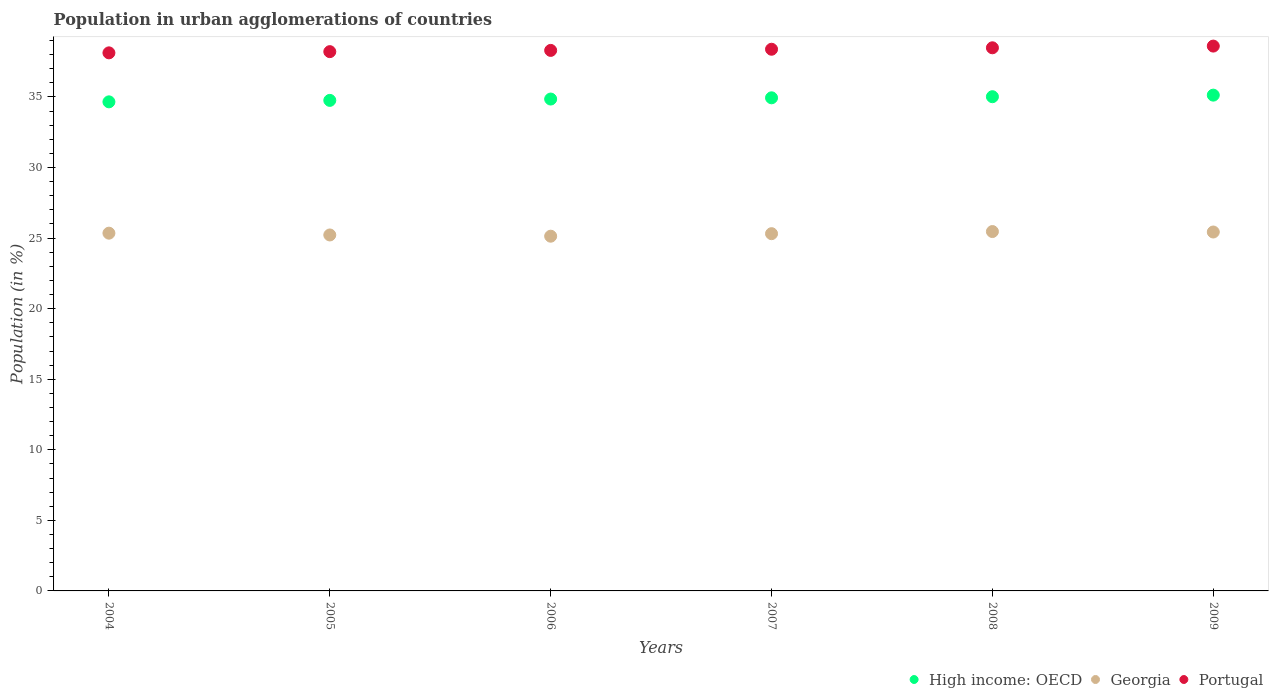What is the percentage of population in urban agglomerations in Portugal in 2005?
Offer a very short reply. 38.21. Across all years, what is the maximum percentage of population in urban agglomerations in Georgia?
Provide a succinct answer. 25.46. Across all years, what is the minimum percentage of population in urban agglomerations in Portugal?
Make the answer very short. 38.13. What is the total percentage of population in urban agglomerations in Georgia in the graph?
Your answer should be very brief. 151.92. What is the difference between the percentage of population in urban agglomerations in Georgia in 2004 and that in 2008?
Provide a succinct answer. -0.11. What is the difference between the percentage of population in urban agglomerations in High income: OECD in 2006 and the percentage of population in urban agglomerations in Portugal in 2008?
Provide a succinct answer. -3.63. What is the average percentage of population in urban agglomerations in Georgia per year?
Offer a very short reply. 25.32. In the year 2008, what is the difference between the percentage of population in urban agglomerations in Portugal and percentage of population in urban agglomerations in High income: OECD?
Provide a succinct answer. 3.47. What is the ratio of the percentage of population in urban agglomerations in Portugal in 2004 to that in 2008?
Provide a short and direct response. 0.99. Is the percentage of population in urban agglomerations in Georgia in 2005 less than that in 2008?
Provide a succinct answer. Yes. Is the difference between the percentage of population in urban agglomerations in Portugal in 2004 and 2006 greater than the difference between the percentage of population in urban agglomerations in High income: OECD in 2004 and 2006?
Provide a short and direct response. Yes. What is the difference between the highest and the second highest percentage of population in urban agglomerations in High income: OECD?
Keep it short and to the point. 0.11. What is the difference between the highest and the lowest percentage of population in urban agglomerations in High income: OECD?
Offer a terse response. 0.48. Is the percentage of population in urban agglomerations in High income: OECD strictly greater than the percentage of population in urban agglomerations in Portugal over the years?
Your response must be concise. No. Is the percentage of population in urban agglomerations in High income: OECD strictly less than the percentage of population in urban agglomerations in Portugal over the years?
Offer a very short reply. Yes. How many years are there in the graph?
Make the answer very short. 6. What is the difference between two consecutive major ticks on the Y-axis?
Ensure brevity in your answer.  5. Are the values on the major ticks of Y-axis written in scientific E-notation?
Make the answer very short. No. Does the graph contain any zero values?
Provide a succinct answer. No. Where does the legend appear in the graph?
Keep it short and to the point. Bottom right. How are the legend labels stacked?
Your answer should be compact. Horizontal. What is the title of the graph?
Your response must be concise. Population in urban agglomerations of countries. Does "Myanmar" appear as one of the legend labels in the graph?
Ensure brevity in your answer.  No. What is the label or title of the Y-axis?
Provide a succinct answer. Population (in %). What is the Population (in %) of High income: OECD in 2004?
Your answer should be very brief. 34.66. What is the Population (in %) in Georgia in 2004?
Offer a very short reply. 25.35. What is the Population (in %) of Portugal in 2004?
Ensure brevity in your answer.  38.13. What is the Population (in %) of High income: OECD in 2005?
Provide a short and direct response. 34.76. What is the Population (in %) in Georgia in 2005?
Give a very brief answer. 25.22. What is the Population (in %) of Portugal in 2005?
Make the answer very short. 38.21. What is the Population (in %) of High income: OECD in 2006?
Offer a very short reply. 34.85. What is the Population (in %) of Georgia in 2006?
Your answer should be very brief. 25.14. What is the Population (in %) in Portugal in 2006?
Offer a very short reply. 38.3. What is the Population (in %) in High income: OECD in 2007?
Give a very brief answer. 34.94. What is the Population (in %) in Georgia in 2007?
Give a very brief answer. 25.31. What is the Population (in %) of Portugal in 2007?
Offer a very short reply. 38.38. What is the Population (in %) of High income: OECD in 2008?
Provide a succinct answer. 35.02. What is the Population (in %) of Georgia in 2008?
Provide a succinct answer. 25.46. What is the Population (in %) in Portugal in 2008?
Make the answer very short. 38.49. What is the Population (in %) of High income: OECD in 2009?
Your answer should be compact. 35.13. What is the Population (in %) in Georgia in 2009?
Provide a succinct answer. 25.43. What is the Population (in %) in Portugal in 2009?
Offer a very short reply. 38.61. Across all years, what is the maximum Population (in %) of High income: OECD?
Provide a short and direct response. 35.13. Across all years, what is the maximum Population (in %) of Georgia?
Make the answer very short. 25.46. Across all years, what is the maximum Population (in %) in Portugal?
Ensure brevity in your answer.  38.61. Across all years, what is the minimum Population (in %) of High income: OECD?
Offer a terse response. 34.66. Across all years, what is the minimum Population (in %) of Georgia?
Offer a terse response. 25.14. Across all years, what is the minimum Population (in %) of Portugal?
Keep it short and to the point. 38.13. What is the total Population (in %) of High income: OECD in the graph?
Offer a very short reply. 209.36. What is the total Population (in %) of Georgia in the graph?
Offer a very short reply. 151.92. What is the total Population (in %) of Portugal in the graph?
Give a very brief answer. 230.12. What is the difference between the Population (in %) in High income: OECD in 2004 and that in 2005?
Make the answer very short. -0.1. What is the difference between the Population (in %) in Georgia in 2004 and that in 2005?
Provide a short and direct response. 0.13. What is the difference between the Population (in %) of Portugal in 2004 and that in 2005?
Keep it short and to the point. -0.09. What is the difference between the Population (in %) in High income: OECD in 2004 and that in 2006?
Ensure brevity in your answer.  -0.2. What is the difference between the Population (in %) in Georgia in 2004 and that in 2006?
Provide a succinct answer. 0.21. What is the difference between the Population (in %) in Portugal in 2004 and that in 2006?
Offer a very short reply. -0.17. What is the difference between the Population (in %) of High income: OECD in 2004 and that in 2007?
Your response must be concise. -0.29. What is the difference between the Population (in %) of Georgia in 2004 and that in 2007?
Offer a very short reply. 0.04. What is the difference between the Population (in %) in Portugal in 2004 and that in 2007?
Your answer should be compact. -0.26. What is the difference between the Population (in %) of High income: OECD in 2004 and that in 2008?
Your answer should be very brief. -0.36. What is the difference between the Population (in %) in Georgia in 2004 and that in 2008?
Keep it short and to the point. -0.11. What is the difference between the Population (in %) of Portugal in 2004 and that in 2008?
Offer a terse response. -0.36. What is the difference between the Population (in %) in High income: OECD in 2004 and that in 2009?
Provide a short and direct response. -0.48. What is the difference between the Population (in %) in Georgia in 2004 and that in 2009?
Your answer should be compact. -0.08. What is the difference between the Population (in %) in Portugal in 2004 and that in 2009?
Your answer should be compact. -0.48. What is the difference between the Population (in %) of High income: OECD in 2005 and that in 2006?
Your response must be concise. -0.09. What is the difference between the Population (in %) in Georgia in 2005 and that in 2006?
Offer a terse response. 0.09. What is the difference between the Population (in %) in Portugal in 2005 and that in 2006?
Make the answer very short. -0.09. What is the difference between the Population (in %) of High income: OECD in 2005 and that in 2007?
Your response must be concise. -0.18. What is the difference between the Population (in %) in Georgia in 2005 and that in 2007?
Provide a succinct answer. -0.09. What is the difference between the Population (in %) in Portugal in 2005 and that in 2007?
Keep it short and to the point. -0.17. What is the difference between the Population (in %) in High income: OECD in 2005 and that in 2008?
Provide a succinct answer. -0.26. What is the difference between the Population (in %) of Georgia in 2005 and that in 2008?
Your answer should be compact. -0.24. What is the difference between the Population (in %) in Portugal in 2005 and that in 2008?
Your response must be concise. -0.27. What is the difference between the Population (in %) of High income: OECD in 2005 and that in 2009?
Make the answer very short. -0.37. What is the difference between the Population (in %) of Georgia in 2005 and that in 2009?
Your answer should be very brief. -0.21. What is the difference between the Population (in %) of Portugal in 2005 and that in 2009?
Ensure brevity in your answer.  -0.39. What is the difference between the Population (in %) in High income: OECD in 2006 and that in 2007?
Your response must be concise. -0.09. What is the difference between the Population (in %) of Georgia in 2006 and that in 2007?
Provide a succinct answer. -0.18. What is the difference between the Population (in %) of Portugal in 2006 and that in 2007?
Ensure brevity in your answer.  -0.08. What is the difference between the Population (in %) of High income: OECD in 2006 and that in 2008?
Provide a succinct answer. -0.17. What is the difference between the Population (in %) of Georgia in 2006 and that in 2008?
Provide a short and direct response. -0.33. What is the difference between the Population (in %) in Portugal in 2006 and that in 2008?
Your response must be concise. -0.18. What is the difference between the Population (in %) in High income: OECD in 2006 and that in 2009?
Your response must be concise. -0.28. What is the difference between the Population (in %) of Georgia in 2006 and that in 2009?
Provide a succinct answer. -0.3. What is the difference between the Population (in %) in Portugal in 2006 and that in 2009?
Keep it short and to the point. -0.31. What is the difference between the Population (in %) of High income: OECD in 2007 and that in 2008?
Your answer should be compact. -0.08. What is the difference between the Population (in %) in Georgia in 2007 and that in 2008?
Ensure brevity in your answer.  -0.15. What is the difference between the Population (in %) in Portugal in 2007 and that in 2008?
Your answer should be very brief. -0.1. What is the difference between the Population (in %) of High income: OECD in 2007 and that in 2009?
Provide a short and direct response. -0.19. What is the difference between the Population (in %) in Georgia in 2007 and that in 2009?
Your answer should be compact. -0.12. What is the difference between the Population (in %) of Portugal in 2007 and that in 2009?
Make the answer very short. -0.22. What is the difference between the Population (in %) of High income: OECD in 2008 and that in 2009?
Offer a very short reply. -0.11. What is the difference between the Population (in %) in Georgia in 2008 and that in 2009?
Your answer should be very brief. 0.03. What is the difference between the Population (in %) in Portugal in 2008 and that in 2009?
Your answer should be compact. -0.12. What is the difference between the Population (in %) of High income: OECD in 2004 and the Population (in %) of Georgia in 2005?
Give a very brief answer. 9.43. What is the difference between the Population (in %) of High income: OECD in 2004 and the Population (in %) of Portugal in 2005?
Your answer should be very brief. -3.56. What is the difference between the Population (in %) in Georgia in 2004 and the Population (in %) in Portugal in 2005?
Provide a short and direct response. -12.86. What is the difference between the Population (in %) of High income: OECD in 2004 and the Population (in %) of Georgia in 2006?
Offer a very short reply. 9.52. What is the difference between the Population (in %) of High income: OECD in 2004 and the Population (in %) of Portugal in 2006?
Your answer should be compact. -3.65. What is the difference between the Population (in %) in Georgia in 2004 and the Population (in %) in Portugal in 2006?
Offer a terse response. -12.95. What is the difference between the Population (in %) in High income: OECD in 2004 and the Population (in %) in Georgia in 2007?
Ensure brevity in your answer.  9.34. What is the difference between the Population (in %) of High income: OECD in 2004 and the Population (in %) of Portugal in 2007?
Your response must be concise. -3.73. What is the difference between the Population (in %) of Georgia in 2004 and the Population (in %) of Portugal in 2007?
Provide a succinct answer. -13.03. What is the difference between the Population (in %) in High income: OECD in 2004 and the Population (in %) in Georgia in 2008?
Give a very brief answer. 9.19. What is the difference between the Population (in %) in High income: OECD in 2004 and the Population (in %) in Portugal in 2008?
Your answer should be compact. -3.83. What is the difference between the Population (in %) in Georgia in 2004 and the Population (in %) in Portugal in 2008?
Your response must be concise. -13.14. What is the difference between the Population (in %) of High income: OECD in 2004 and the Population (in %) of Georgia in 2009?
Offer a very short reply. 9.22. What is the difference between the Population (in %) of High income: OECD in 2004 and the Population (in %) of Portugal in 2009?
Make the answer very short. -3.95. What is the difference between the Population (in %) of Georgia in 2004 and the Population (in %) of Portugal in 2009?
Give a very brief answer. -13.26. What is the difference between the Population (in %) of High income: OECD in 2005 and the Population (in %) of Georgia in 2006?
Provide a short and direct response. 9.62. What is the difference between the Population (in %) of High income: OECD in 2005 and the Population (in %) of Portugal in 2006?
Provide a succinct answer. -3.54. What is the difference between the Population (in %) of Georgia in 2005 and the Population (in %) of Portugal in 2006?
Provide a short and direct response. -13.08. What is the difference between the Population (in %) of High income: OECD in 2005 and the Population (in %) of Georgia in 2007?
Provide a succinct answer. 9.45. What is the difference between the Population (in %) of High income: OECD in 2005 and the Population (in %) of Portugal in 2007?
Your answer should be compact. -3.62. What is the difference between the Population (in %) in Georgia in 2005 and the Population (in %) in Portugal in 2007?
Keep it short and to the point. -13.16. What is the difference between the Population (in %) of High income: OECD in 2005 and the Population (in %) of Georgia in 2008?
Give a very brief answer. 9.29. What is the difference between the Population (in %) in High income: OECD in 2005 and the Population (in %) in Portugal in 2008?
Provide a succinct answer. -3.73. What is the difference between the Population (in %) in Georgia in 2005 and the Population (in %) in Portugal in 2008?
Provide a succinct answer. -13.26. What is the difference between the Population (in %) in High income: OECD in 2005 and the Population (in %) in Georgia in 2009?
Your response must be concise. 9.33. What is the difference between the Population (in %) in High income: OECD in 2005 and the Population (in %) in Portugal in 2009?
Offer a very short reply. -3.85. What is the difference between the Population (in %) in Georgia in 2005 and the Population (in %) in Portugal in 2009?
Your response must be concise. -13.38. What is the difference between the Population (in %) in High income: OECD in 2006 and the Population (in %) in Georgia in 2007?
Ensure brevity in your answer.  9.54. What is the difference between the Population (in %) in High income: OECD in 2006 and the Population (in %) in Portugal in 2007?
Offer a very short reply. -3.53. What is the difference between the Population (in %) in Georgia in 2006 and the Population (in %) in Portugal in 2007?
Offer a very short reply. -13.25. What is the difference between the Population (in %) in High income: OECD in 2006 and the Population (in %) in Georgia in 2008?
Make the answer very short. 9.39. What is the difference between the Population (in %) in High income: OECD in 2006 and the Population (in %) in Portugal in 2008?
Offer a very short reply. -3.63. What is the difference between the Population (in %) in Georgia in 2006 and the Population (in %) in Portugal in 2008?
Provide a succinct answer. -13.35. What is the difference between the Population (in %) in High income: OECD in 2006 and the Population (in %) in Georgia in 2009?
Give a very brief answer. 9.42. What is the difference between the Population (in %) in High income: OECD in 2006 and the Population (in %) in Portugal in 2009?
Offer a very short reply. -3.75. What is the difference between the Population (in %) of Georgia in 2006 and the Population (in %) of Portugal in 2009?
Keep it short and to the point. -13.47. What is the difference between the Population (in %) of High income: OECD in 2007 and the Population (in %) of Georgia in 2008?
Provide a succinct answer. 9.48. What is the difference between the Population (in %) of High income: OECD in 2007 and the Population (in %) of Portugal in 2008?
Offer a very short reply. -3.54. What is the difference between the Population (in %) in Georgia in 2007 and the Population (in %) in Portugal in 2008?
Provide a succinct answer. -13.17. What is the difference between the Population (in %) of High income: OECD in 2007 and the Population (in %) of Georgia in 2009?
Provide a succinct answer. 9.51. What is the difference between the Population (in %) in High income: OECD in 2007 and the Population (in %) in Portugal in 2009?
Offer a terse response. -3.67. What is the difference between the Population (in %) in Georgia in 2007 and the Population (in %) in Portugal in 2009?
Provide a succinct answer. -13.29. What is the difference between the Population (in %) of High income: OECD in 2008 and the Population (in %) of Georgia in 2009?
Offer a very short reply. 9.59. What is the difference between the Population (in %) in High income: OECD in 2008 and the Population (in %) in Portugal in 2009?
Offer a terse response. -3.59. What is the difference between the Population (in %) of Georgia in 2008 and the Population (in %) of Portugal in 2009?
Offer a terse response. -13.14. What is the average Population (in %) in High income: OECD per year?
Provide a short and direct response. 34.89. What is the average Population (in %) in Georgia per year?
Make the answer very short. 25.32. What is the average Population (in %) of Portugal per year?
Provide a short and direct response. 38.35. In the year 2004, what is the difference between the Population (in %) in High income: OECD and Population (in %) in Georgia?
Offer a very short reply. 9.31. In the year 2004, what is the difference between the Population (in %) in High income: OECD and Population (in %) in Portugal?
Keep it short and to the point. -3.47. In the year 2004, what is the difference between the Population (in %) of Georgia and Population (in %) of Portugal?
Offer a terse response. -12.78. In the year 2005, what is the difference between the Population (in %) in High income: OECD and Population (in %) in Georgia?
Your answer should be very brief. 9.54. In the year 2005, what is the difference between the Population (in %) in High income: OECD and Population (in %) in Portugal?
Keep it short and to the point. -3.45. In the year 2005, what is the difference between the Population (in %) of Georgia and Population (in %) of Portugal?
Keep it short and to the point. -12.99. In the year 2006, what is the difference between the Population (in %) in High income: OECD and Population (in %) in Georgia?
Provide a short and direct response. 9.72. In the year 2006, what is the difference between the Population (in %) in High income: OECD and Population (in %) in Portugal?
Offer a very short reply. -3.45. In the year 2006, what is the difference between the Population (in %) in Georgia and Population (in %) in Portugal?
Your answer should be very brief. -13.17. In the year 2007, what is the difference between the Population (in %) in High income: OECD and Population (in %) in Georgia?
Keep it short and to the point. 9.63. In the year 2007, what is the difference between the Population (in %) in High income: OECD and Population (in %) in Portugal?
Your response must be concise. -3.44. In the year 2007, what is the difference between the Population (in %) in Georgia and Population (in %) in Portugal?
Provide a short and direct response. -13.07. In the year 2008, what is the difference between the Population (in %) in High income: OECD and Population (in %) in Georgia?
Offer a very short reply. 9.55. In the year 2008, what is the difference between the Population (in %) in High income: OECD and Population (in %) in Portugal?
Ensure brevity in your answer.  -3.47. In the year 2008, what is the difference between the Population (in %) in Georgia and Population (in %) in Portugal?
Your answer should be compact. -13.02. In the year 2009, what is the difference between the Population (in %) of High income: OECD and Population (in %) of Georgia?
Provide a short and direct response. 9.7. In the year 2009, what is the difference between the Population (in %) of High income: OECD and Population (in %) of Portugal?
Your response must be concise. -3.48. In the year 2009, what is the difference between the Population (in %) in Georgia and Population (in %) in Portugal?
Keep it short and to the point. -13.17. What is the ratio of the Population (in %) of Georgia in 2004 to that in 2005?
Keep it short and to the point. 1.01. What is the ratio of the Population (in %) in Portugal in 2004 to that in 2005?
Make the answer very short. 1. What is the ratio of the Population (in %) of Georgia in 2004 to that in 2006?
Make the answer very short. 1.01. What is the ratio of the Population (in %) of High income: OECD in 2004 to that in 2007?
Give a very brief answer. 0.99. What is the ratio of the Population (in %) in Georgia in 2004 to that in 2007?
Ensure brevity in your answer.  1. What is the ratio of the Population (in %) of Portugal in 2004 to that in 2008?
Keep it short and to the point. 0.99. What is the ratio of the Population (in %) in High income: OECD in 2004 to that in 2009?
Your answer should be compact. 0.99. What is the ratio of the Population (in %) of Georgia in 2004 to that in 2009?
Ensure brevity in your answer.  1. What is the ratio of the Population (in %) in Portugal in 2004 to that in 2009?
Offer a very short reply. 0.99. What is the ratio of the Population (in %) in Portugal in 2005 to that in 2006?
Make the answer very short. 1. What is the ratio of the Population (in %) in High income: OECD in 2005 to that in 2007?
Your answer should be compact. 0.99. What is the ratio of the Population (in %) in Georgia in 2005 to that in 2007?
Offer a very short reply. 1. What is the ratio of the Population (in %) in Portugal in 2005 to that in 2007?
Your response must be concise. 1. What is the ratio of the Population (in %) of High income: OECD in 2005 to that in 2008?
Provide a succinct answer. 0.99. What is the ratio of the Population (in %) in Georgia in 2005 to that in 2008?
Your response must be concise. 0.99. What is the ratio of the Population (in %) in Georgia in 2005 to that in 2009?
Provide a succinct answer. 0.99. What is the ratio of the Population (in %) in Portugal in 2006 to that in 2007?
Keep it short and to the point. 1. What is the ratio of the Population (in %) in Georgia in 2006 to that in 2008?
Keep it short and to the point. 0.99. What is the ratio of the Population (in %) in High income: OECD in 2006 to that in 2009?
Offer a very short reply. 0.99. What is the ratio of the Population (in %) in Georgia in 2006 to that in 2009?
Offer a very short reply. 0.99. What is the ratio of the Population (in %) in Portugal in 2006 to that in 2009?
Keep it short and to the point. 0.99. What is the ratio of the Population (in %) of High income: OECD in 2007 to that in 2008?
Give a very brief answer. 1. What is the ratio of the Population (in %) of Georgia in 2007 to that in 2008?
Your answer should be very brief. 0.99. What is the ratio of the Population (in %) in Portugal in 2007 to that in 2008?
Your answer should be compact. 1. What is the ratio of the Population (in %) in High income: OECD in 2007 to that in 2009?
Keep it short and to the point. 0.99. What is the ratio of the Population (in %) in High income: OECD in 2008 to that in 2009?
Your response must be concise. 1. What is the ratio of the Population (in %) of Portugal in 2008 to that in 2009?
Provide a succinct answer. 1. What is the difference between the highest and the second highest Population (in %) of High income: OECD?
Provide a short and direct response. 0.11. What is the difference between the highest and the second highest Population (in %) of Georgia?
Offer a terse response. 0.03. What is the difference between the highest and the second highest Population (in %) in Portugal?
Your answer should be very brief. 0.12. What is the difference between the highest and the lowest Population (in %) in High income: OECD?
Give a very brief answer. 0.48. What is the difference between the highest and the lowest Population (in %) in Georgia?
Offer a terse response. 0.33. What is the difference between the highest and the lowest Population (in %) in Portugal?
Keep it short and to the point. 0.48. 